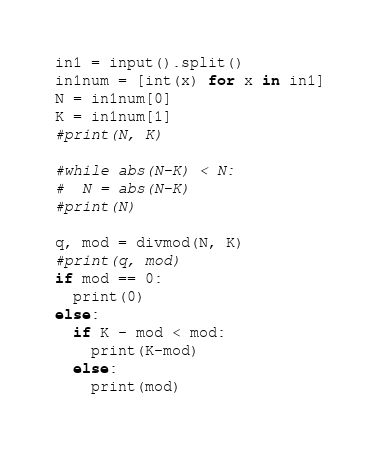Convert code to text. <code><loc_0><loc_0><loc_500><loc_500><_Python_>in1 = input().split()
in1num = [int(x) for x in in1]
N = in1num[0]
K = in1num[1]
#print(N, K)

#while abs(N-K) < N:
#  N = abs(N-K)
#print(N)

q, mod = divmod(N, K)
#print(q, mod)
if mod == 0:
  print(0)
else:
  if K - mod < mod:
    print(K-mod)
  else:
    print(mod)</code> 